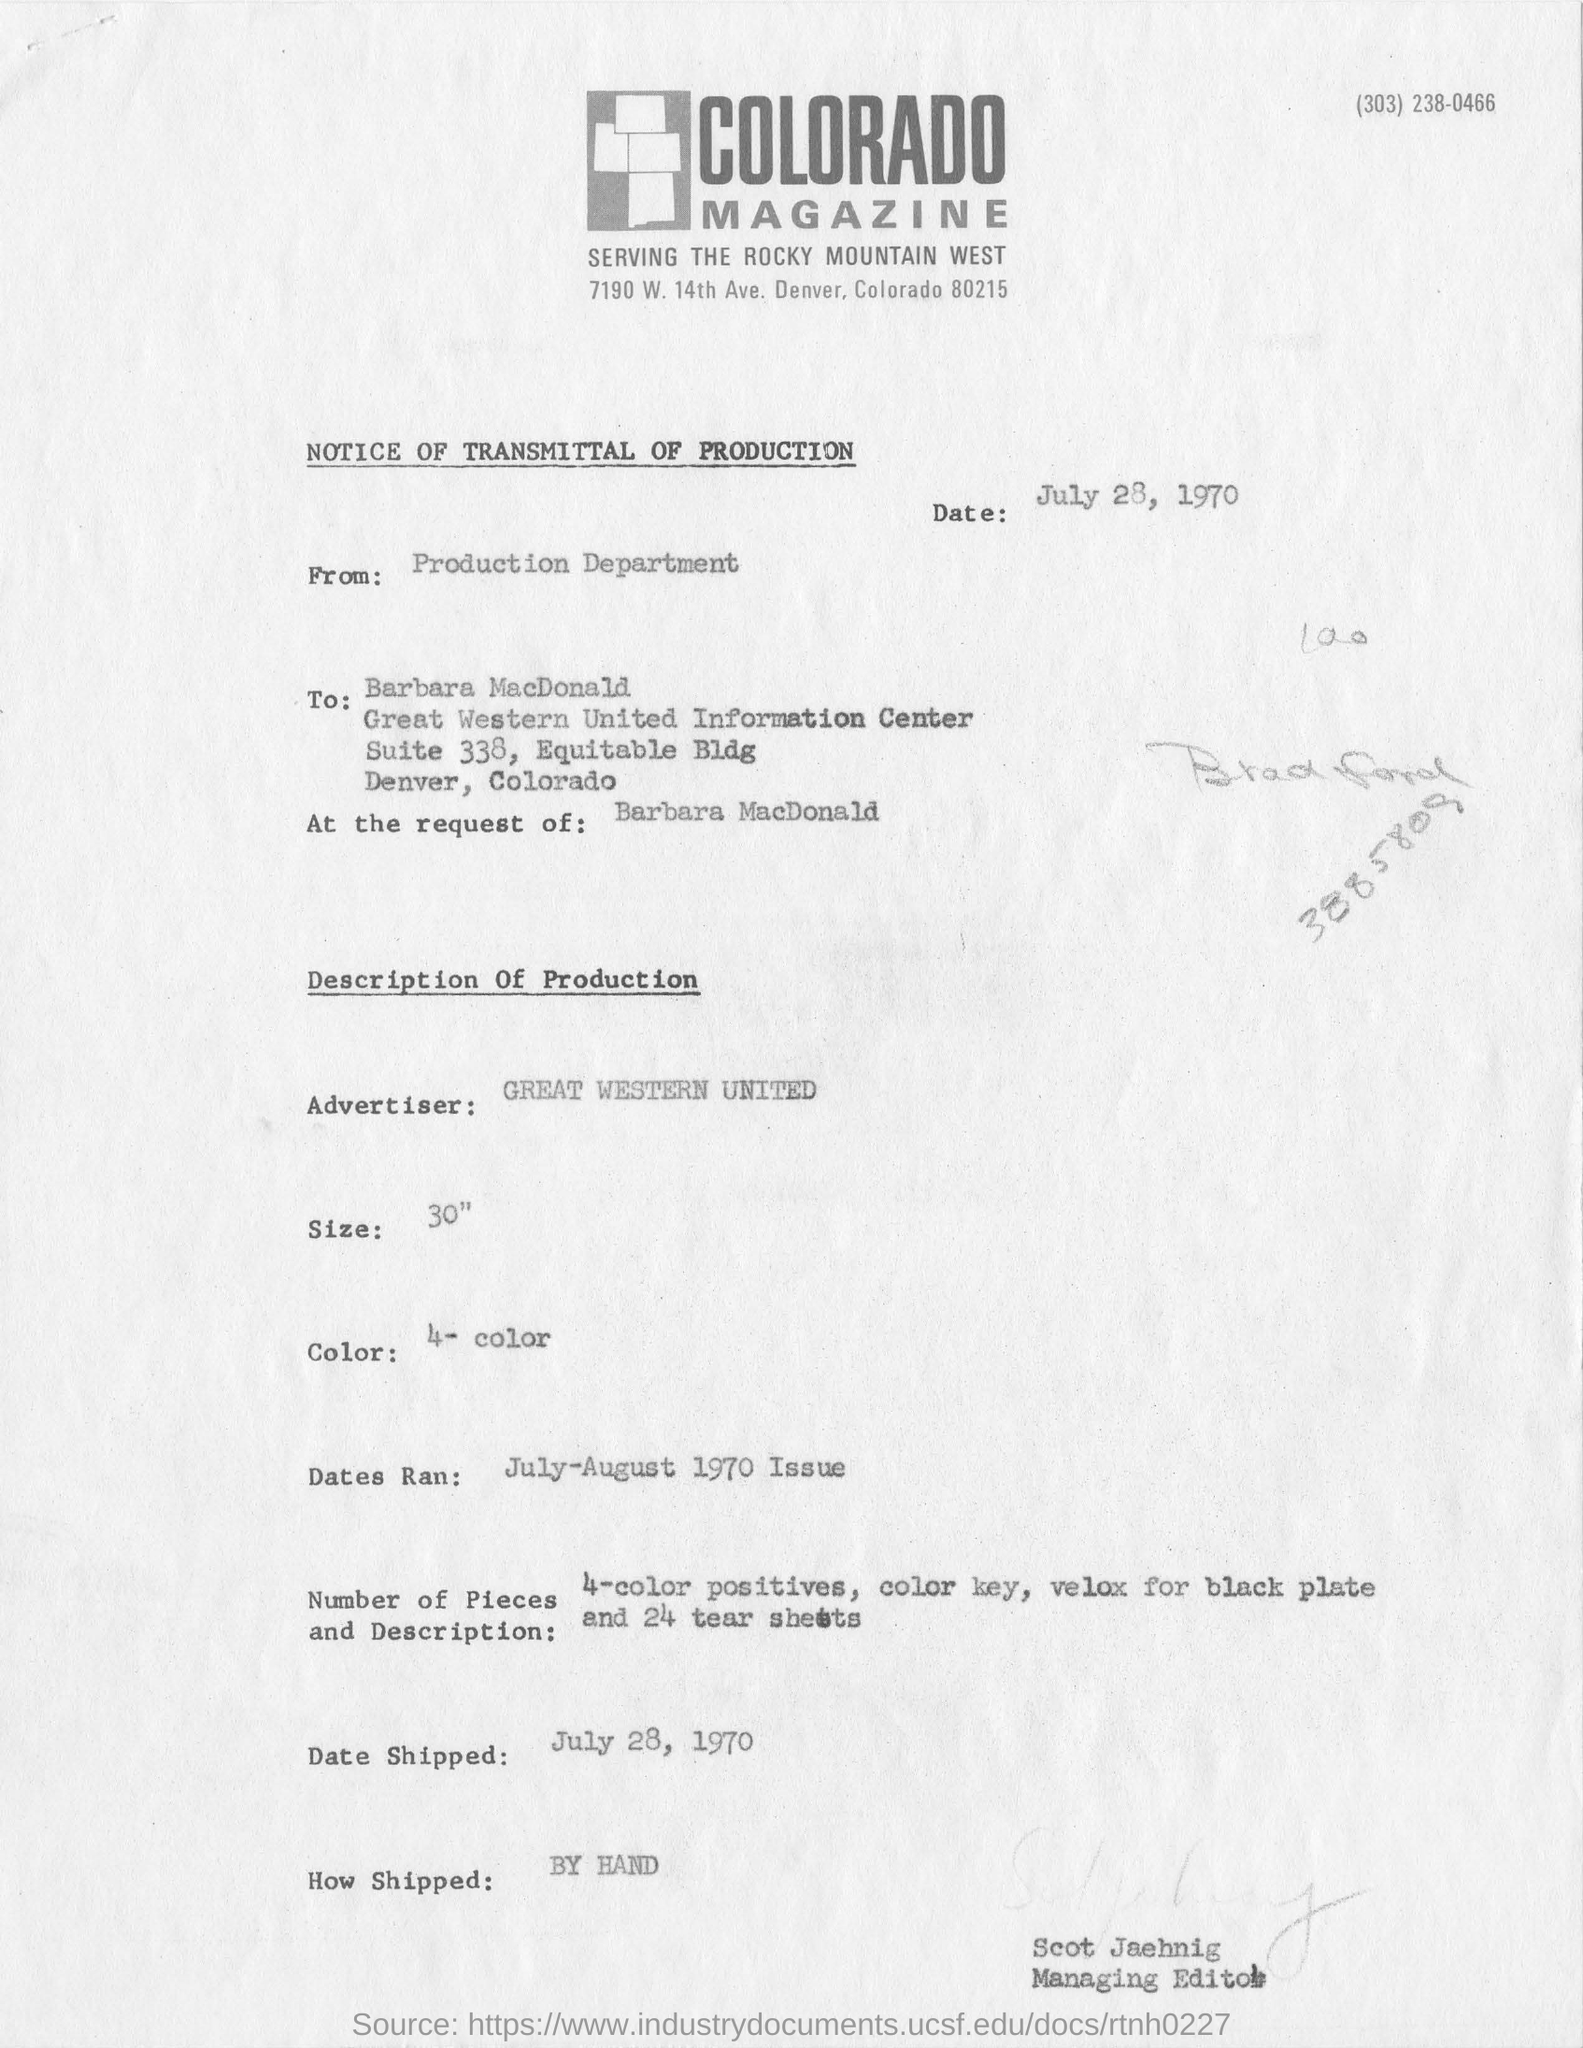What is written in Top Right of the document ?
Give a very brief answer. (303) 238-0466. Which is the advertiser company mentioned here?
Your response must be concise. GREAT WESTERN UNITED. What is the date mentioned in the top of the document ?
Provide a succinct answer. July 28, 1970. What type of Notice is this?
Make the answer very short. NOTICE OF TRANSMITTAL OF PRODUCTION. Who sent this ?
Offer a terse response. Production Department. Who is the recipient of the notice?
Ensure brevity in your answer.  Barbara MacDonald. Who is the Advertiser ?
Make the answer very short. GREAT WESTERN UNITED. How many colors ?
Make the answer very short. 4- color. What is the Shipping Date ?
Keep it short and to the point. July 28, 1970. 